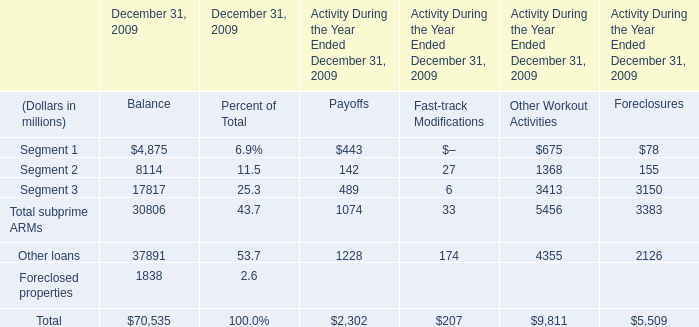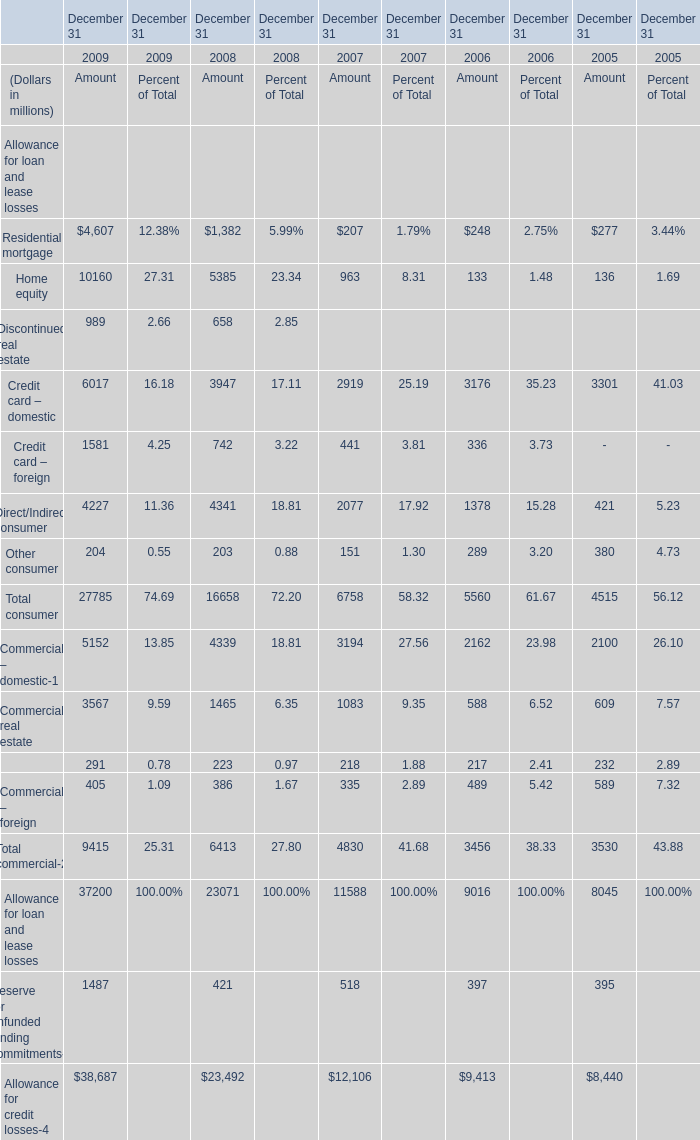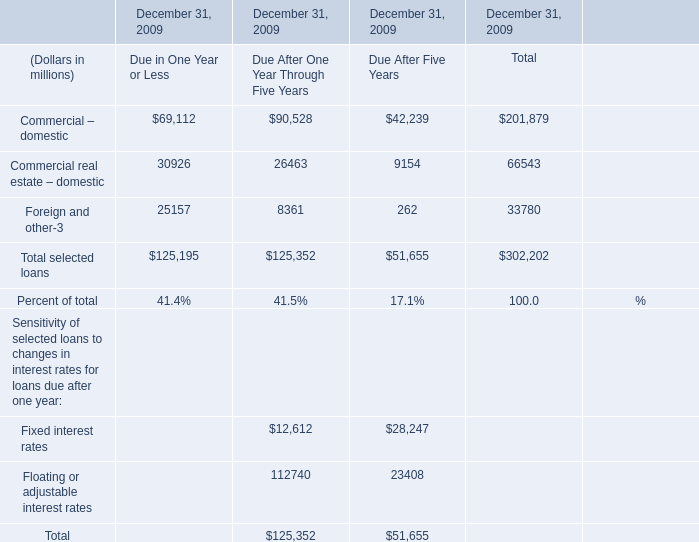What's the average of Credit card – domestic and Credit card – foreign in 2009? (in million) 
Computations: ((6017 + 1581) / 2)
Answer: 3799.0. 